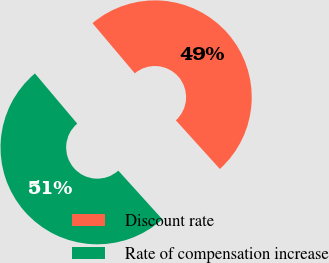Convert chart to OTSL. <chart><loc_0><loc_0><loc_500><loc_500><pie_chart><fcel>Discount rate<fcel>Rate of compensation increase<nl><fcel>49.44%<fcel>50.56%<nl></chart> 